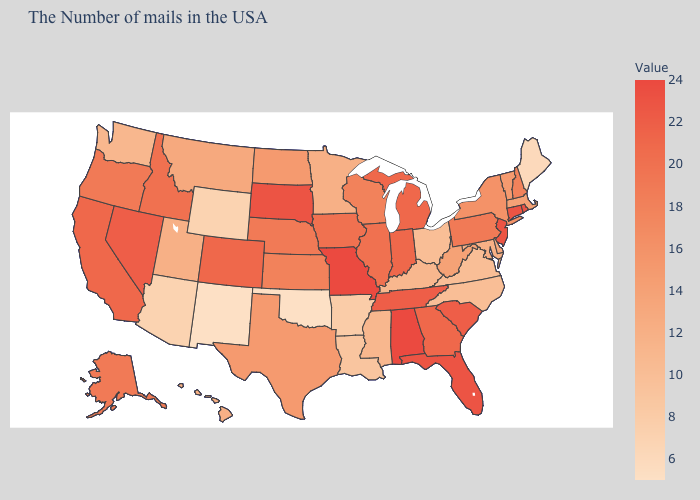Which states have the lowest value in the USA?
Write a very short answer. Oklahoma, New Mexico. Is the legend a continuous bar?
Be succinct. Yes. Is the legend a continuous bar?
Keep it brief. Yes. Among the states that border Tennessee , which have the highest value?
Short answer required. Alabama, Missouri. Does the map have missing data?
Be succinct. No. 